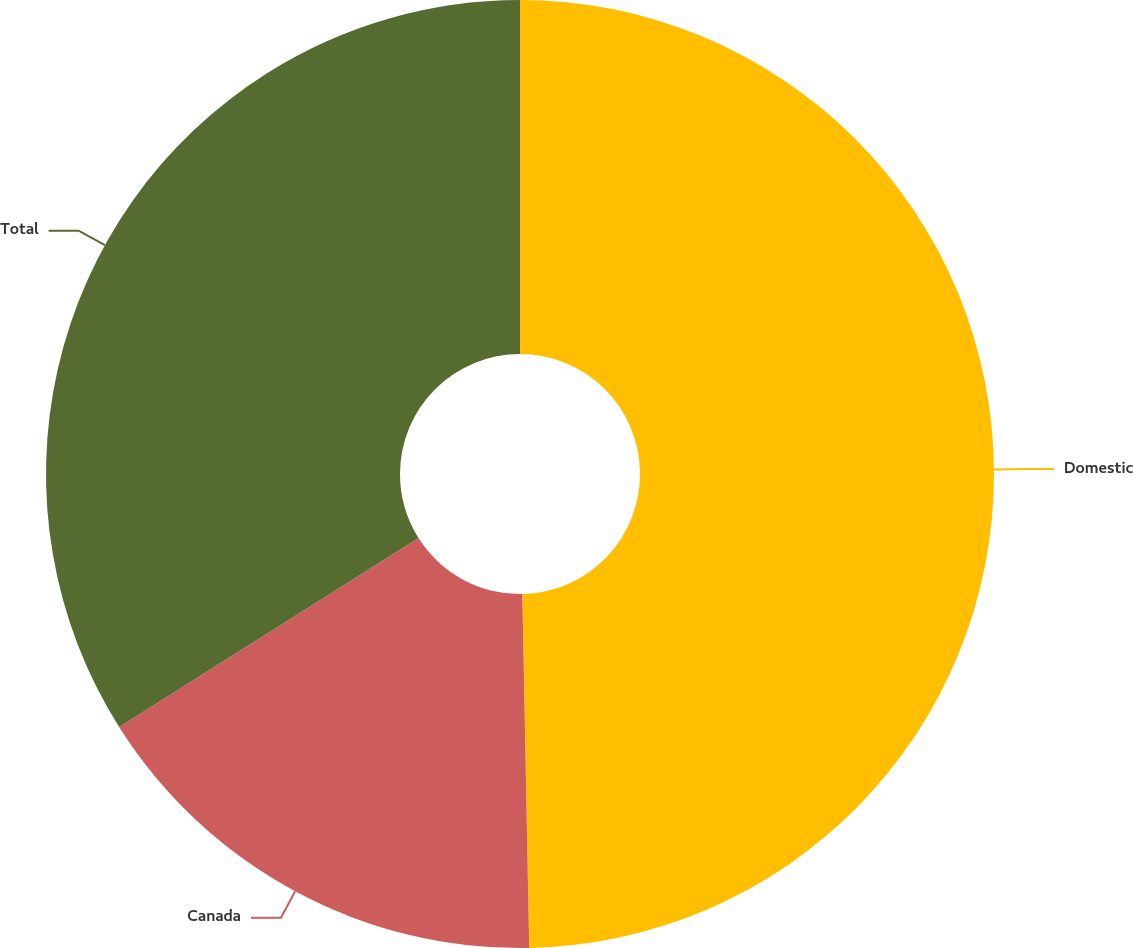<chart> <loc_0><loc_0><loc_500><loc_500><pie_chart><fcel>Domestic<fcel>Canada<fcel>Total<nl><fcel>49.69%<fcel>16.35%<fcel>33.96%<nl></chart> 